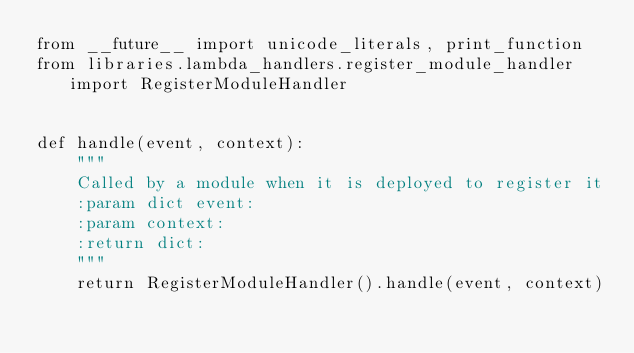<code> <loc_0><loc_0><loc_500><loc_500><_Python_>from __future__ import unicode_literals, print_function
from libraries.lambda_handlers.register_module_handler import RegisterModuleHandler


def handle(event, context):
    """
    Called by a module when it is deployed to register it
    :param dict event:
    :param context:
    :return dict:
    """
    return RegisterModuleHandler().handle(event, context)
</code> 